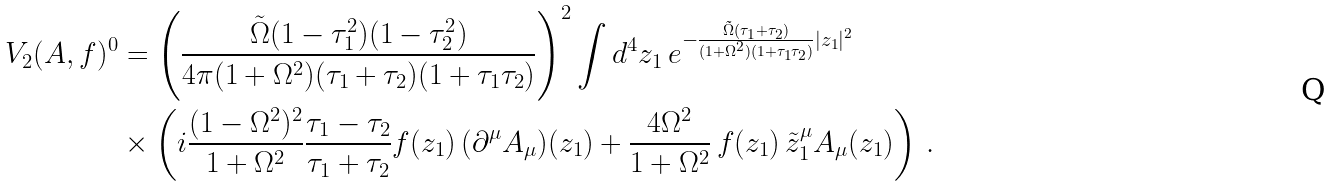Convert formula to latex. <formula><loc_0><loc_0><loc_500><loc_500>V _ { 2 } ( A , f ) ^ { 0 } & = \left ( \frac { \tilde { \Omega } ( 1 - \tau _ { 1 } ^ { 2 } ) ( 1 - \tau _ { 2 } ^ { 2 } ) } { 4 \pi ( 1 + \Omega ^ { 2 } ) ( \tau _ { 1 } + \tau _ { 2 } ) ( 1 + \tau _ { 1 } \tau _ { 2 } ) } \right ) ^ { 2 } \int d ^ { 4 } z _ { 1 } \, e ^ { - \frac { \tilde { \Omega } ( \tau _ { 1 } + \tau _ { 2 } ) } { ( 1 + \Omega ^ { 2 } ) ( 1 + \tau _ { 1 } \tau _ { 2 } ) } | z _ { 1 } | ^ { 2 } } \\ & \times \left ( i \frac { ( 1 - \Omega ^ { 2 } ) ^ { 2 } } { 1 + \Omega ^ { 2 } } \frac { \tau _ { 1 } - \tau _ { 2 } } { \tau _ { 1 } + \tau _ { 2 } } f ( z _ { 1 } ) \, ( \partial ^ { \mu } A _ { \mu } ) ( z _ { 1 } ) + \frac { 4 \Omega ^ { 2 } } { 1 + \Omega ^ { 2 } } \, f ( z _ { 1 } ) \, \tilde { z } _ { 1 } ^ { \mu } A _ { \mu } ( z _ { 1 } ) \right ) \, .</formula> 